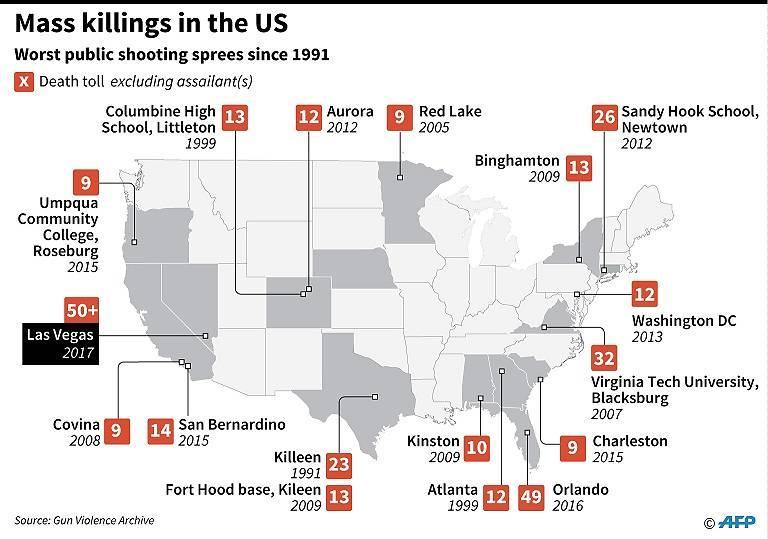What was the death toll in the earliest shooting spree shown in this image?
Answer the question with a short phrase. 23 How many public shooting incidents are listed in this image? 17 What was the death toll in the most recent shooting spree shown in this image? 50+ In which city did the most recent public shooting incident shown in this image happen? Las Vegas In which year did the public shooting incident happen in Charleston? 2015 In which place did the 2005 shooting incident happen? Red Lake The incident with second highest death toll took place in which year? 2016 The shooting incident in Atlanta took place in which year? 1999 The incident with second highest death toll took place in which city? Orlando In which year did a public shooting incident occur in San Bernardino? 2015 